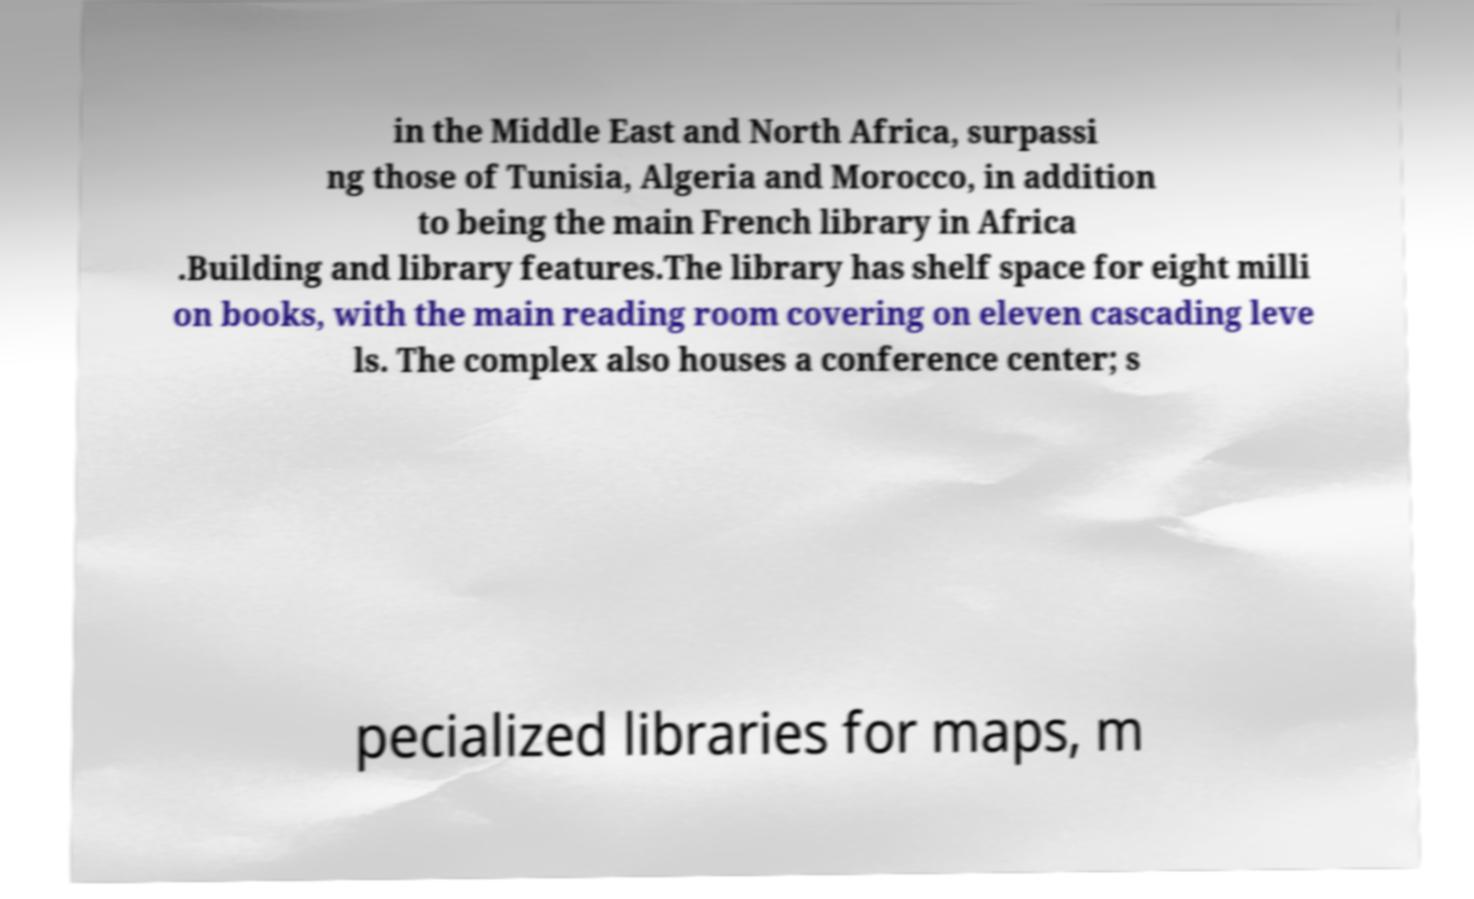Could you extract and type out the text from this image? in the Middle East and North Africa, surpassi ng those of Tunisia, Algeria and Morocco, in addition to being the main French library in Africa .Building and library features.The library has shelf space for eight milli on books, with the main reading room covering on eleven cascading leve ls. The complex also houses a conference center; s pecialized libraries for maps, m 